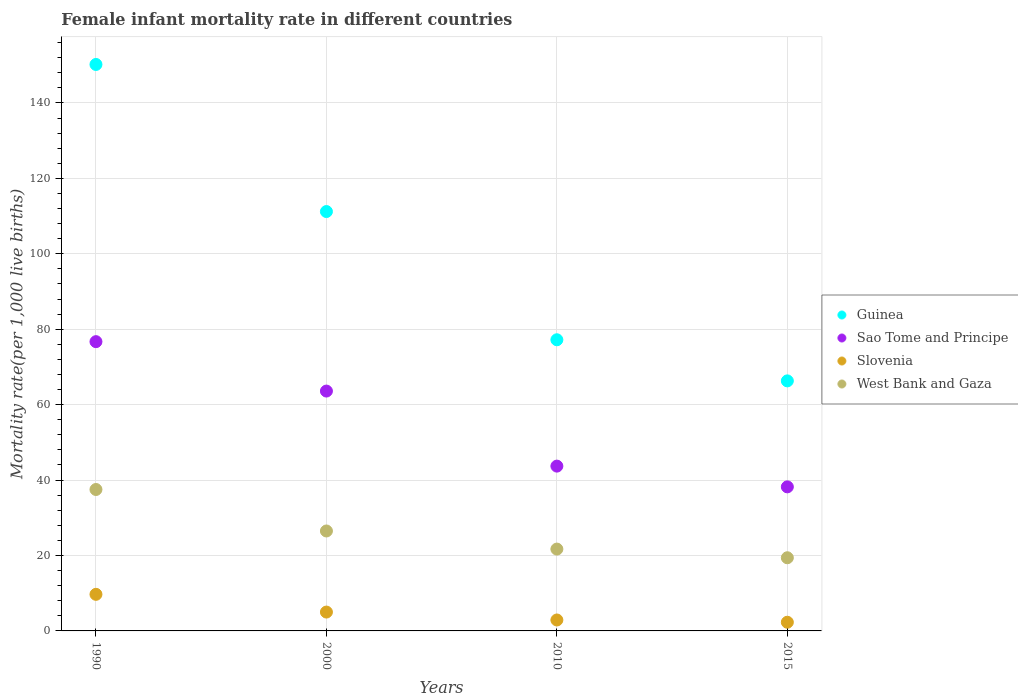How many different coloured dotlines are there?
Provide a succinct answer. 4. Is the number of dotlines equal to the number of legend labels?
Make the answer very short. Yes. What is the female infant mortality rate in West Bank and Gaza in 2000?
Your answer should be compact. 26.5. Across all years, what is the maximum female infant mortality rate in Guinea?
Your response must be concise. 150.2. Across all years, what is the minimum female infant mortality rate in Guinea?
Provide a short and direct response. 66.3. In which year was the female infant mortality rate in Guinea maximum?
Your answer should be very brief. 1990. In which year was the female infant mortality rate in Slovenia minimum?
Offer a terse response. 2015. What is the difference between the female infant mortality rate in Guinea in 2000 and that in 2010?
Offer a terse response. 34. What is the difference between the female infant mortality rate in Sao Tome and Principe in 2000 and the female infant mortality rate in West Bank and Gaza in 1990?
Offer a very short reply. 26.1. What is the average female infant mortality rate in West Bank and Gaza per year?
Your response must be concise. 26.27. In the year 2000, what is the difference between the female infant mortality rate in Guinea and female infant mortality rate in Slovenia?
Your answer should be very brief. 106.2. In how many years, is the female infant mortality rate in Slovenia greater than 108?
Ensure brevity in your answer.  0. What is the ratio of the female infant mortality rate in Slovenia in 2010 to that in 2015?
Your answer should be very brief. 1.26. What is the difference between the highest and the second highest female infant mortality rate in Sao Tome and Principe?
Offer a very short reply. 13.1. What is the difference between the highest and the lowest female infant mortality rate in Sao Tome and Principe?
Your response must be concise. 38.5. In how many years, is the female infant mortality rate in Sao Tome and Principe greater than the average female infant mortality rate in Sao Tome and Principe taken over all years?
Ensure brevity in your answer.  2. Is the sum of the female infant mortality rate in Sao Tome and Principe in 2010 and 2015 greater than the maximum female infant mortality rate in Guinea across all years?
Your answer should be very brief. No. Is it the case that in every year, the sum of the female infant mortality rate in Slovenia and female infant mortality rate in Guinea  is greater than the sum of female infant mortality rate in West Bank and Gaza and female infant mortality rate in Sao Tome and Principe?
Make the answer very short. Yes. Is it the case that in every year, the sum of the female infant mortality rate in Sao Tome and Principe and female infant mortality rate in West Bank and Gaza  is greater than the female infant mortality rate in Guinea?
Offer a very short reply. No. Does the female infant mortality rate in West Bank and Gaza monotonically increase over the years?
Ensure brevity in your answer.  No. Is the female infant mortality rate in Sao Tome and Principe strictly greater than the female infant mortality rate in Slovenia over the years?
Your answer should be compact. Yes. Does the graph contain any zero values?
Offer a terse response. No. Does the graph contain grids?
Give a very brief answer. Yes. How are the legend labels stacked?
Your answer should be compact. Vertical. What is the title of the graph?
Your answer should be very brief. Female infant mortality rate in different countries. What is the label or title of the X-axis?
Make the answer very short. Years. What is the label or title of the Y-axis?
Your answer should be very brief. Mortality rate(per 1,0 live births). What is the Mortality rate(per 1,000 live births) in Guinea in 1990?
Keep it short and to the point. 150.2. What is the Mortality rate(per 1,000 live births) of Sao Tome and Principe in 1990?
Your answer should be compact. 76.7. What is the Mortality rate(per 1,000 live births) in West Bank and Gaza in 1990?
Provide a short and direct response. 37.5. What is the Mortality rate(per 1,000 live births) in Guinea in 2000?
Give a very brief answer. 111.2. What is the Mortality rate(per 1,000 live births) of Sao Tome and Principe in 2000?
Give a very brief answer. 63.6. What is the Mortality rate(per 1,000 live births) of Guinea in 2010?
Your response must be concise. 77.2. What is the Mortality rate(per 1,000 live births) of Sao Tome and Principe in 2010?
Offer a very short reply. 43.7. What is the Mortality rate(per 1,000 live births) in West Bank and Gaza in 2010?
Provide a short and direct response. 21.7. What is the Mortality rate(per 1,000 live births) of Guinea in 2015?
Make the answer very short. 66.3. What is the Mortality rate(per 1,000 live births) in Sao Tome and Principe in 2015?
Your answer should be very brief. 38.2. Across all years, what is the maximum Mortality rate(per 1,000 live births) in Guinea?
Make the answer very short. 150.2. Across all years, what is the maximum Mortality rate(per 1,000 live births) in Sao Tome and Principe?
Your response must be concise. 76.7. Across all years, what is the maximum Mortality rate(per 1,000 live births) in West Bank and Gaza?
Your answer should be compact. 37.5. Across all years, what is the minimum Mortality rate(per 1,000 live births) of Guinea?
Your response must be concise. 66.3. Across all years, what is the minimum Mortality rate(per 1,000 live births) in Sao Tome and Principe?
Give a very brief answer. 38.2. Across all years, what is the minimum Mortality rate(per 1,000 live births) of West Bank and Gaza?
Offer a very short reply. 19.4. What is the total Mortality rate(per 1,000 live births) of Guinea in the graph?
Your answer should be compact. 404.9. What is the total Mortality rate(per 1,000 live births) in Sao Tome and Principe in the graph?
Your answer should be very brief. 222.2. What is the total Mortality rate(per 1,000 live births) of Slovenia in the graph?
Your answer should be compact. 19.9. What is the total Mortality rate(per 1,000 live births) of West Bank and Gaza in the graph?
Provide a short and direct response. 105.1. What is the difference between the Mortality rate(per 1,000 live births) in West Bank and Gaza in 1990 and that in 2000?
Offer a very short reply. 11. What is the difference between the Mortality rate(per 1,000 live births) of Sao Tome and Principe in 1990 and that in 2010?
Provide a short and direct response. 33. What is the difference between the Mortality rate(per 1,000 live births) in West Bank and Gaza in 1990 and that in 2010?
Your response must be concise. 15.8. What is the difference between the Mortality rate(per 1,000 live births) of Guinea in 1990 and that in 2015?
Give a very brief answer. 83.9. What is the difference between the Mortality rate(per 1,000 live births) in Sao Tome and Principe in 1990 and that in 2015?
Give a very brief answer. 38.5. What is the difference between the Mortality rate(per 1,000 live births) of Guinea in 2000 and that in 2010?
Provide a short and direct response. 34. What is the difference between the Mortality rate(per 1,000 live births) in West Bank and Gaza in 2000 and that in 2010?
Your response must be concise. 4.8. What is the difference between the Mortality rate(per 1,000 live births) in Guinea in 2000 and that in 2015?
Your answer should be compact. 44.9. What is the difference between the Mortality rate(per 1,000 live births) of Sao Tome and Principe in 2000 and that in 2015?
Make the answer very short. 25.4. What is the difference between the Mortality rate(per 1,000 live births) of Slovenia in 2010 and that in 2015?
Your answer should be very brief. 0.6. What is the difference between the Mortality rate(per 1,000 live births) in West Bank and Gaza in 2010 and that in 2015?
Provide a succinct answer. 2.3. What is the difference between the Mortality rate(per 1,000 live births) in Guinea in 1990 and the Mortality rate(per 1,000 live births) in Sao Tome and Principe in 2000?
Your answer should be very brief. 86.6. What is the difference between the Mortality rate(per 1,000 live births) in Guinea in 1990 and the Mortality rate(per 1,000 live births) in Slovenia in 2000?
Provide a short and direct response. 145.2. What is the difference between the Mortality rate(per 1,000 live births) of Guinea in 1990 and the Mortality rate(per 1,000 live births) of West Bank and Gaza in 2000?
Provide a succinct answer. 123.7. What is the difference between the Mortality rate(per 1,000 live births) of Sao Tome and Principe in 1990 and the Mortality rate(per 1,000 live births) of Slovenia in 2000?
Provide a succinct answer. 71.7. What is the difference between the Mortality rate(per 1,000 live births) in Sao Tome and Principe in 1990 and the Mortality rate(per 1,000 live births) in West Bank and Gaza in 2000?
Make the answer very short. 50.2. What is the difference between the Mortality rate(per 1,000 live births) in Slovenia in 1990 and the Mortality rate(per 1,000 live births) in West Bank and Gaza in 2000?
Give a very brief answer. -16.8. What is the difference between the Mortality rate(per 1,000 live births) in Guinea in 1990 and the Mortality rate(per 1,000 live births) in Sao Tome and Principe in 2010?
Keep it short and to the point. 106.5. What is the difference between the Mortality rate(per 1,000 live births) of Guinea in 1990 and the Mortality rate(per 1,000 live births) of Slovenia in 2010?
Provide a succinct answer. 147.3. What is the difference between the Mortality rate(per 1,000 live births) in Guinea in 1990 and the Mortality rate(per 1,000 live births) in West Bank and Gaza in 2010?
Your answer should be compact. 128.5. What is the difference between the Mortality rate(per 1,000 live births) in Sao Tome and Principe in 1990 and the Mortality rate(per 1,000 live births) in Slovenia in 2010?
Your answer should be very brief. 73.8. What is the difference between the Mortality rate(per 1,000 live births) of Sao Tome and Principe in 1990 and the Mortality rate(per 1,000 live births) of West Bank and Gaza in 2010?
Provide a succinct answer. 55. What is the difference between the Mortality rate(per 1,000 live births) in Guinea in 1990 and the Mortality rate(per 1,000 live births) in Sao Tome and Principe in 2015?
Keep it short and to the point. 112. What is the difference between the Mortality rate(per 1,000 live births) of Guinea in 1990 and the Mortality rate(per 1,000 live births) of Slovenia in 2015?
Your response must be concise. 147.9. What is the difference between the Mortality rate(per 1,000 live births) in Guinea in 1990 and the Mortality rate(per 1,000 live births) in West Bank and Gaza in 2015?
Your answer should be very brief. 130.8. What is the difference between the Mortality rate(per 1,000 live births) of Sao Tome and Principe in 1990 and the Mortality rate(per 1,000 live births) of Slovenia in 2015?
Your answer should be compact. 74.4. What is the difference between the Mortality rate(per 1,000 live births) in Sao Tome and Principe in 1990 and the Mortality rate(per 1,000 live births) in West Bank and Gaza in 2015?
Your answer should be compact. 57.3. What is the difference between the Mortality rate(per 1,000 live births) of Guinea in 2000 and the Mortality rate(per 1,000 live births) of Sao Tome and Principe in 2010?
Offer a very short reply. 67.5. What is the difference between the Mortality rate(per 1,000 live births) in Guinea in 2000 and the Mortality rate(per 1,000 live births) in Slovenia in 2010?
Keep it short and to the point. 108.3. What is the difference between the Mortality rate(per 1,000 live births) in Guinea in 2000 and the Mortality rate(per 1,000 live births) in West Bank and Gaza in 2010?
Offer a very short reply. 89.5. What is the difference between the Mortality rate(per 1,000 live births) of Sao Tome and Principe in 2000 and the Mortality rate(per 1,000 live births) of Slovenia in 2010?
Keep it short and to the point. 60.7. What is the difference between the Mortality rate(per 1,000 live births) of Sao Tome and Principe in 2000 and the Mortality rate(per 1,000 live births) of West Bank and Gaza in 2010?
Your response must be concise. 41.9. What is the difference between the Mortality rate(per 1,000 live births) of Slovenia in 2000 and the Mortality rate(per 1,000 live births) of West Bank and Gaza in 2010?
Offer a terse response. -16.7. What is the difference between the Mortality rate(per 1,000 live births) in Guinea in 2000 and the Mortality rate(per 1,000 live births) in Slovenia in 2015?
Your answer should be compact. 108.9. What is the difference between the Mortality rate(per 1,000 live births) in Guinea in 2000 and the Mortality rate(per 1,000 live births) in West Bank and Gaza in 2015?
Your answer should be compact. 91.8. What is the difference between the Mortality rate(per 1,000 live births) in Sao Tome and Principe in 2000 and the Mortality rate(per 1,000 live births) in Slovenia in 2015?
Your answer should be compact. 61.3. What is the difference between the Mortality rate(per 1,000 live births) of Sao Tome and Principe in 2000 and the Mortality rate(per 1,000 live births) of West Bank and Gaza in 2015?
Offer a very short reply. 44.2. What is the difference between the Mortality rate(per 1,000 live births) in Slovenia in 2000 and the Mortality rate(per 1,000 live births) in West Bank and Gaza in 2015?
Your response must be concise. -14.4. What is the difference between the Mortality rate(per 1,000 live births) of Guinea in 2010 and the Mortality rate(per 1,000 live births) of Slovenia in 2015?
Ensure brevity in your answer.  74.9. What is the difference between the Mortality rate(per 1,000 live births) of Guinea in 2010 and the Mortality rate(per 1,000 live births) of West Bank and Gaza in 2015?
Provide a short and direct response. 57.8. What is the difference between the Mortality rate(per 1,000 live births) of Sao Tome and Principe in 2010 and the Mortality rate(per 1,000 live births) of Slovenia in 2015?
Ensure brevity in your answer.  41.4. What is the difference between the Mortality rate(per 1,000 live births) of Sao Tome and Principe in 2010 and the Mortality rate(per 1,000 live births) of West Bank and Gaza in 2015?
Your answer should be very brief. 24.3. What is the difference between the Mortality rate(per 1,000 live births) in Slovenia in 2010 and the Mortality rate(per 1,000 live births) in West Bank and Gaza in 2015?
Provide a succinct answer. -16.5. What is the average Mortality rate(per 1,000 live births) in Guinea per year?
Make the answer very short. 101.22. What is the average Mortality rate(per 1,000 live births) of Sao Tome and Principe per year?
Keep it short and to the point. 55.55. What is the average Mortality rate(per 1,000 live births) of Slovenia per year?
Your answer should be compact. 4.97. What is the average Mortality rate(per 1,000 live births) in West Bank and Gaza per year?
Ensure brevity in your answer.  26.27. In the year 1990, what is the difference between the Mortality rate(per 1,000 live births) in Guinea and Mortality rate(per 1,000 live births) in Sao Tome and Principe?
Provide a succinct answer. 73.5. In the year 1990, what is the difference between the Mortality rate(per 1,000 live births) of Guinea and Mortality rate(per 1,000 live births) of Slovenia?
Make the answer very short. 140.5. In the year 1990, what is the difference between the Mortality rate(per 1,000 live births) of Guinea and Mortality rate(per 1,000 live births) of West Bank and Gaza?
Your response must be concise. 112.7. In the year 1990, what is the difference between the Mortality rate(per 1,000 live births) in Sao Tome and Principe and Mortality rate(per 1,000 live births) in West Bank and Gaza?
Your answer should be compact. 39.2. In the year 1990, what is the difference between the Mortality rate(per 1,000 live births) of Slovenia and Mortality rate(per 1,000 live births) of West Bank and Gaza?
Give a very brief answer. -27.8. In the year 2000, what is the difference between the Mortality rate(per 1,000 live births) in Guinea and Mortality rate(per 1,000 live births) in Sao Tome and Principe?
Ensure brevity in your answer.  47.6. In the year 2000, what is the difference between the Mortality rate(per 1,000 live births) of Guinea and Mortality rate(per 1,000 live births) of Slovenia?
Provide a short and direct response. 106.2. In the year 2000, what is the difference between the Mortality rate(per 1,000 live births) in Guinea and Mortality rate(per 1,000 live births) in West Bank and Gaza?
Offer a very short reply. 84.7. In the year 2000, what is the difference between the Mortality rate(per 1,000 live births) of Sao Tome and Principe and Mortality rate(per 1,000 live births) of Slovenia?
Make the answer very short. 58.6. In the year 2000, what is the difference between the Mortality rate(per 1,000 live births) of Sao Tome and Principe and Mortality rate(per 1,000 live births) of West Bank and Gaza?
Your response must be concise. 37.1. In the year 2000, what is the difference between the Mortality rate(per 1,000 live births) of Slovenia and Mortality rate(per 1,000 live births) of West Bank and Gaza?
Ensure brevity in your answer.  -21.5. In the year 2010, what is the difference between the Mortality rate(per 1,000 live births) in Guinea and Mortality rate(per 1,000 live births) in Sao Tome and Principe?
Your answer should be compact. 33.5. In the year 2010, what is the difference between the Mortality rate(per 1,000 live births) in Guinea and Mortality rate(per 1,000 live births) in Slovenia?
Keep it short and to the point. 74.3. In the year 2010, what is the difference between the Mortality rate(per 1,000 live births) of Guinea and Mortality rate(per 1,000 live births) of West Bank and Gaza?
Ensure brevity in your answer.  55.5. In the year 2010, what is the difference between the Mortality rate(per 1,000 live births) in Sao Tome and Principe and Mortality rate(per 1,000 live births) in Slovenia?
Make the answer very short. 40.8. In the year 2010, what is the difference between the Mortality rate(per 1,000 live births) of Slovenia and Mortality rate(per 1,000 live births) of West Bank and Gaza?
Offer a very short reply. -18.8. In the year 2015, what is the difference between the Mortality rate(per 1,000 live births) in Guinea and Mortality rate(per 1,000 live births) in Sao Tome and Principe?
Offer a very short reply. 28.1. In the year 2015, what is the difference between the Mortality rate(per 1,000 live births) in Guinea and Mortality rate(per 1,000 live births) in Slovenia?
Your response must be concise. 64. In the year 2015, what is the difference between the Mortality rate(per 1,000 live births) of Guinea and Mortality rate(per 1,000 live births) of West Bank and Gaza?
Provide a succinct answer. 46.9. In the year 2015, what is the difference between the Mortality rate(per 1,000 live births) of Sao Tome and Principe and Mortality rate(per 1,000 live births) of Slovenia?
Offer a terse response. 35.9. In the year 2015, what is the difference between the Mortality rate(per 1,000 live births) of Sao Tome and Principe and Mortality rate(per 1,000 live births) of West Bank and Gaza?
Ensure brevity in your answer.  18.8. In the year 2015, what is the difference between the Mortality rate(per 1,000 live births) in Slovenia and Mortality rate(per 1,000 live births) in West Bank and Gaza?
Make the answer very short. -17.1. What is the ratio of the Mortality rate(per 1,000 live births) in Guinea in 1990 to that in 2000?
Offer a very short reply. 1.35. What is the ratio of the Mortality rate(per 1,000 live births) of Sao Tome and Principe in 1990 to that in 2000?
Offer a terse response. 1.21. What is the ratio of the Mortality rate(per 1,000 live births) in Slovenia in 1990 to that in 2000?
Your answer should be very brief. 1.94. What is the ratio of the Mortality rate(per 1,000 live births) of West Bank and Gaza in 1990 to that in 2000?
Your response must be concise. 1.42. What is the ratio of the Mortality rate(per 1,000 live births) of Guinea in 1990 to that in 2010?
Ensure brevity in your answer.  1.95. What is the ratio of the Mortality rate(per 1,000 live births) in Sao Tome and Principe in 1990 to that in 2010?
Offer a terse response. 1.76. What is the ratio of the Mortality rate(per 1,000 live births) of Slovenia in 1990 to that in 2010?
Your response must be concise. 3.34. What is the ratio of the Mortality rate(per 1,000 live births) in West Bank and Gaza in 1990 to that in 2010?
Keep it short and to the point. 1.73. What is the ratio of the Mortality rate(per 1,000 live births) in Guinea in 1990 to that in 2015?
Provide a succinct answer. 2.27. What is the ratio of the Mortality rate(per 1,000 live births) of Sao Tome and Principe in 1990 to that in 2015?
Your answer should be very brief. 2.01. What is the ratio of the Mortality rate(per 1,000 live births) of Slovenia in 1990 to that in 2015?
Make the answer very short. 4.22. What is the ratio of the Mortality rate(per 1,000 live births) in West Bank and Gaza in 1990 to that in 2015?
Offer a terse response. 1.93. What is the ratio of the Mortality rate(per 1,000 live births) of Guinea in 2000 to that in 2010?
Provide a succinct answer. 1.44. What is the ratio of the Mortality rate(per 1,000 live births) of Sao Tome and Principe in 2000 to that in 2010?
Give a very brief answer. 1.46. What is the ratio of the Mortality rate(per 1,000 live births) of Slovenia in 2000 to that in 2010?
Your answer should be compact. 1.72. What is the ratio of the Mortality rate(per 1,000 live births) in West Bank and Gaza in 2000 to that in 2010?
Your answer should be very brief. 1.22. What is the ratio of the Mortality rate(per 1,000 live births) in Guinea in 2000 to that in 2015?
Offer a terse response. 1.68. What is the ratio of the Mortality rate(per 1,000 live births) in Sao Tome and Principe in 2000 to that in 2015?
Your answer should be compact. 1.66. What is the ratio of the Mortality rate(per 1,000 live births) of Slovenia in 2000 to that in 2015?
Your answer should be very brief. 2.17. What is the ratio of the Mortality rate(per 1,000 live births) in West Bank and Gaza in 2000 to that in 2015?
Offer a very short reply. 1.37. What is the ratio of the Mortality rate(per 1,000 live births) of Guinea in 2010 to that in 2015?
Offer a very short reply. 1.16. What is the ratio of the Mortality rate(per 1,000 live births) in Sao Tome and Principe in 2010 to that in 2015?
Your answer should be very brief. 1.14. What is the ratio of the Mortality rate(per 1,000 live births) in Slovenia in 2010 to that in 2015?
Provide a short and direct response. 1.26. What is the ratio of the Mortality rate(per 1,000 live births) of West Bank and Gaza in 2010 to that in 2015?
Make the answer very short. 1.12. What is the difference between the highest and the second highest Mortality rate(per 1,000 live births) of Guinea?
Give a very brief answer. 39. What is the difference between the highest and the second highest Mortality rate(per 1,000 live births) in Sao Tome and Principe?
Your answer should be compact. 13.1. What is the difference between the highest and the second highest Mortality rate(per 1,000 live births) of Slovenia?
Offer a terse response. 4.7. What is the difference between the highest and the second highest Mortality rate(per 1,000 live births) of West Bank and Gaza?
Offer a terse response. 11. What is the difference between the highest and the lowest Mortality rate(per 1,000 live births) of Guinea?
Your answer should be very brief. 83.9. What is the difference between the highest and the lowest Mortality rate(per 1,000 live births) in Sao Tome and Principe?
Offer a terse response. 38.5. 